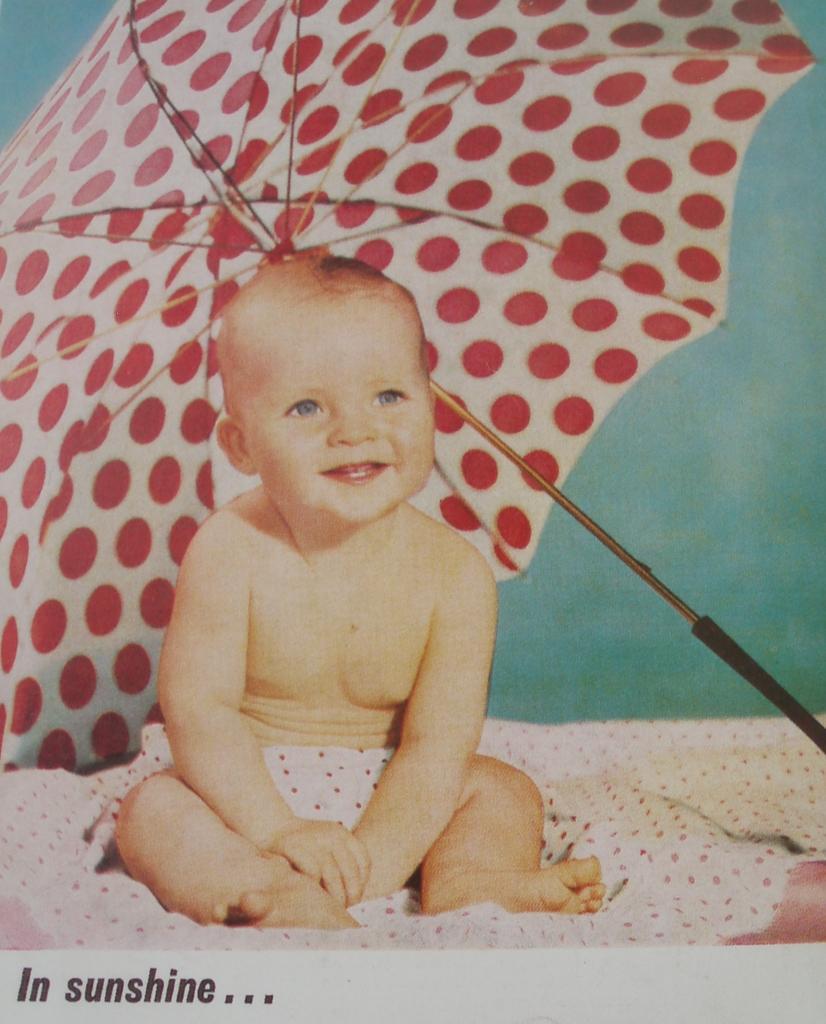How would you summarize this image in a sentence or two? It is a poster. In this image there is a boy sitting on the bed. Behind him there is an umbrella. In the background of the image there is a wall and there is some text at the bottom of the image. 